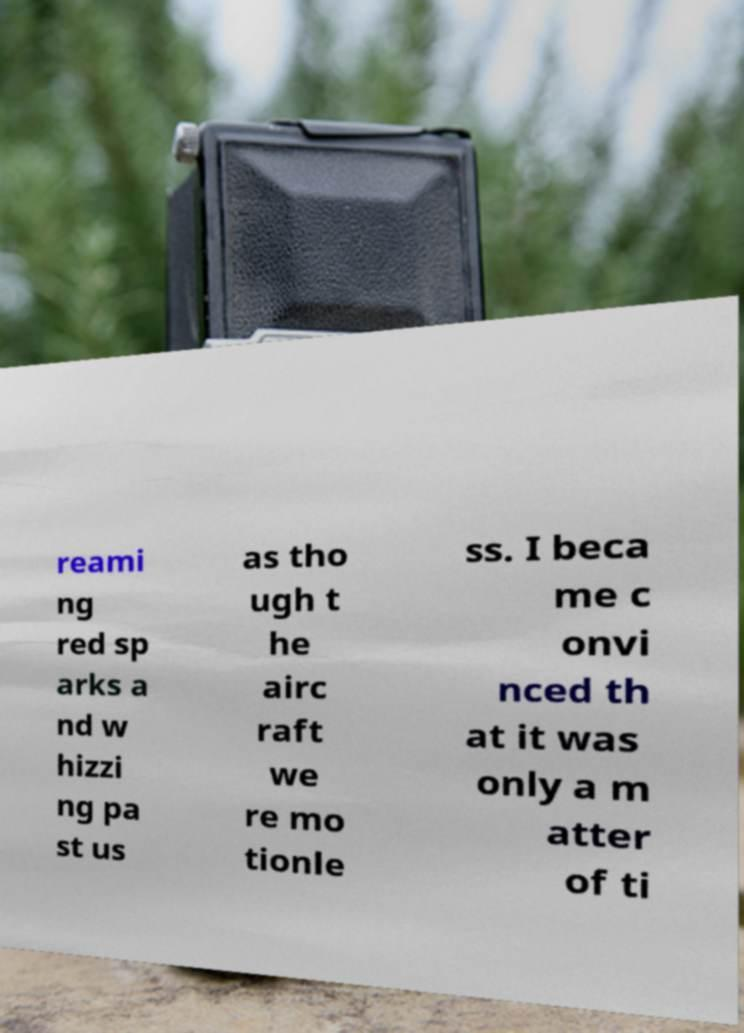For documentation purposes, I need the text within this image transcribed. Could you provide that? reami ng red sp arks a nd w hizzi ng pa st us as tho ugh t he airc raft we re mo tionle ss. I beca me c onvi nced th at it was only a m atter of ti 